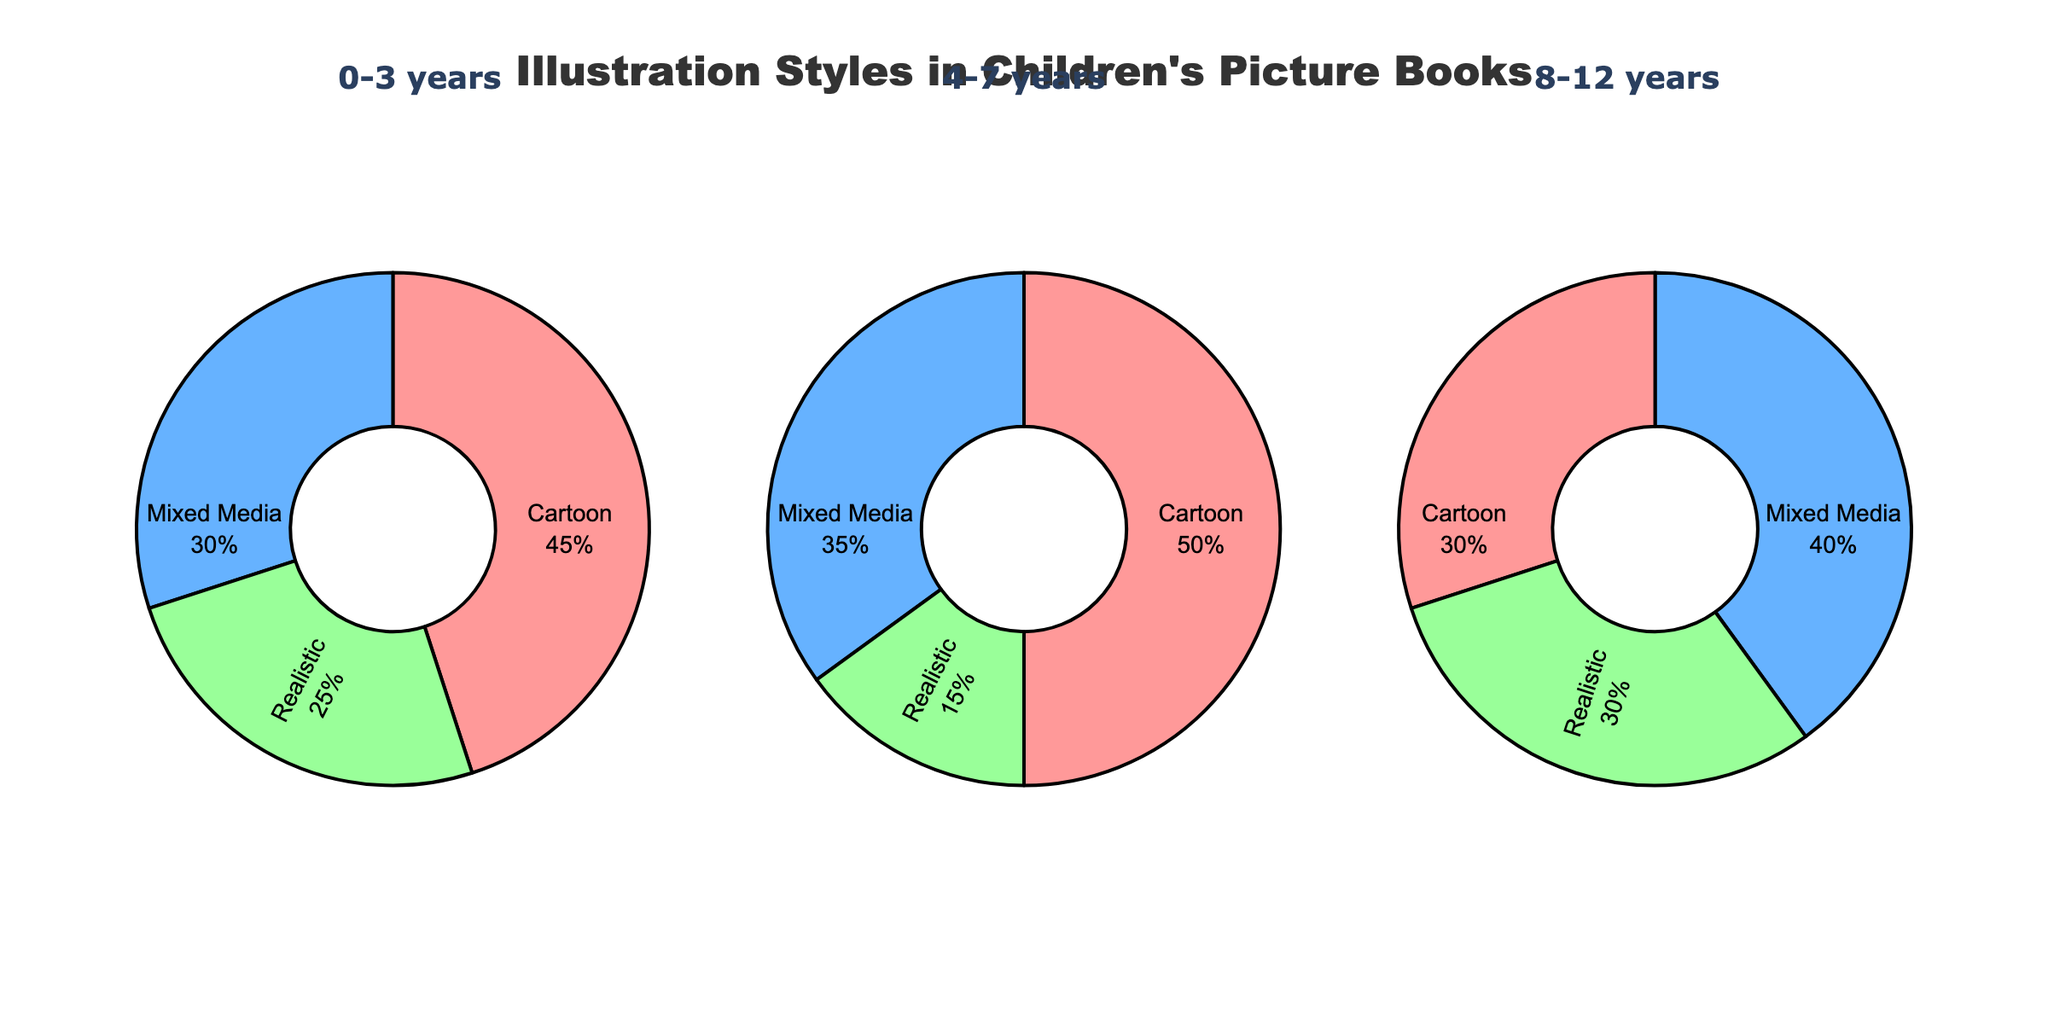What is the title of the figure? The title is placed at the top center of the figure and reads as 'Illustration Styles in Children's Picture Books'.
Answer: Illustration Styles in Children's Picture Books Which illustration style is most used for the 4-7 years age group? The pie chart for the 4-7 years age group shows the largest section labeled 'Cartoon', indicating it is the most used style for this age group.
Answer: Cartoon What is the percentage of Mixed Media style in the 0-3 years age group? In the pie chart for the 0-3 years age group, the portion labeled 'Mixed Media' shows a percentage of 30%.
Answer: 30% Which age group has the highest use of Realistic illustration style? By comparing the Realistic sections in all three pie charts, the 8-12 years age group has the highest value at 30%.
Answer: 8-12 years How does the usage of Cartoon style change from 0-3 years to 8-12 years? For the 0-3 years age group, Cartoon style is 45%. For the 8-12 years age group, it is 30%. Subtract 30% from 45% to find the change.
Answer: Decreases by 15% Which age group has the greatest diversity in illustration styles based on the percentage spread? The 8-12 years age group shows a more even spread among Cartoon (30%), Mixed Media (40%), and Realistic (30%) compared to other age groups which have more dominant styles.
Answer: 8-12 years What is the combined percentage of Mixed Media and Realistic styles for the 4-7 years age group? The percentages for Mixed Media and Realistic styles in the 4-7 years group are 35% and 15% respectively. Adding these gives 35% + 15%.
Answer: 50% What is the difference in the percentage of Realistic style between 0-3 years and 4-7 years age groups? The Realistic style percentage for 0-3 years is 25% and for 4-7 years is 15%. Subtract 15% from 25% to get the difference.
Answer: 10% In which age group is the Cartoon style exactly half of the total illustration style usage? The pie chart for the 4-7 years age group shows that the Cartoon style makes up 50%, which is exactly half.
Answer: 4-7 years 